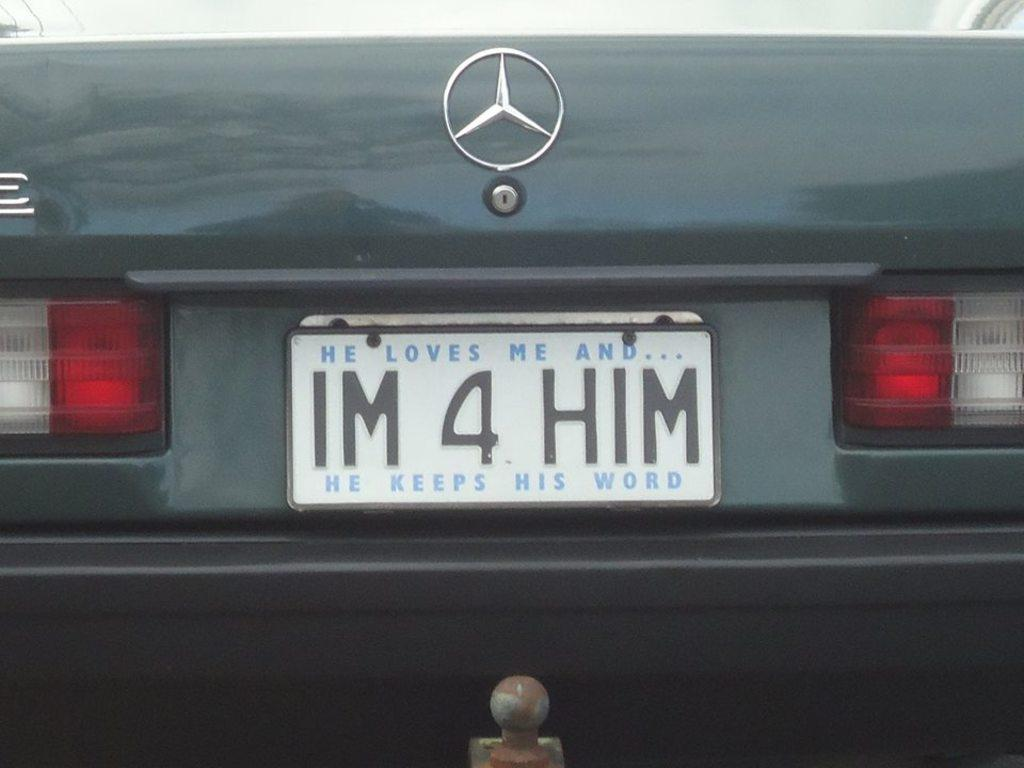<image>
Relay a brief, clear account of the picture shown. "Im 4 Him" responds to the phrase "He loves me and He keeps His word". 